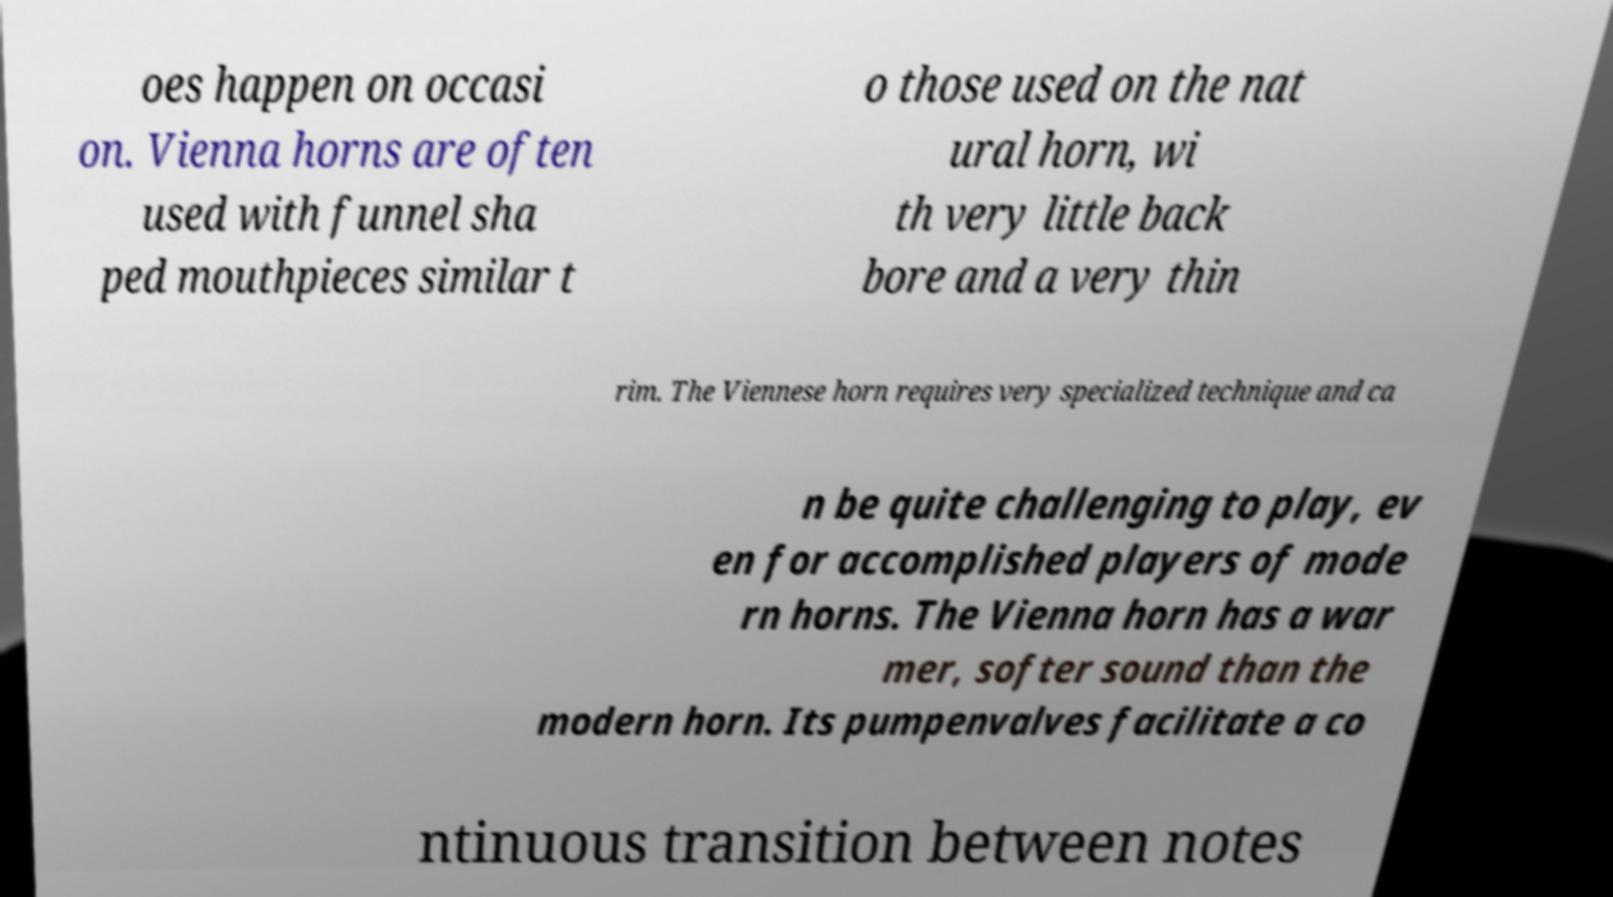I need the written content from this picture converted into text. Can you do that? oes happen on occasi on. Vienna horns are often used with funnel sha ped mouthpieces similar t o those used on the nat ural horn, wi th very little back bore and a very thin rim. The Viennese horn requires very specialized technique and ca n be quite challenging to play, ev en for accomplished players of mode rn horns. The Vienna horn has a war mer, softer sound than the modern horn. Its pumpenvalves facilitate a co ntinuous transition between notes 